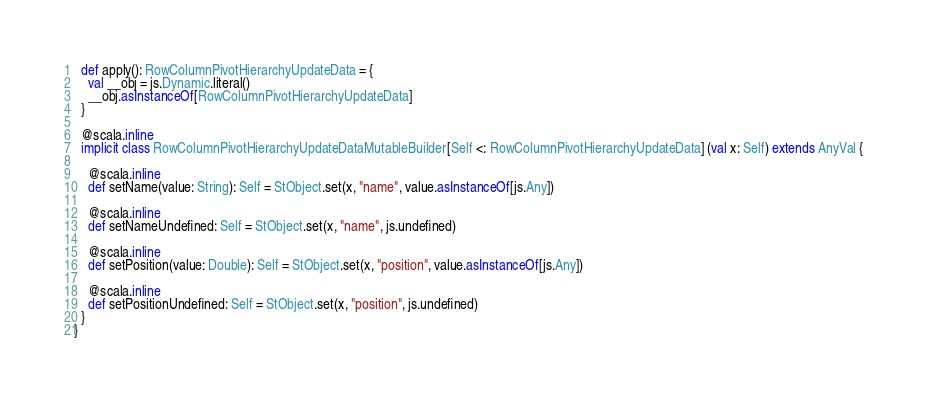Convert code to text. <code><loc_0><loc_0><loc_500><loc_500><_Scala_>  def apply(): RowColumnPivotHierarchyUpdateData = {
    val __obj = js.Dynamic.literal()
    __obj.asInstanceOf[RowColumnPivotHierarchyUpdateData]
  }
  
  @scala.inline
  implicit class RowColumnPivotHierarchyUpdateDataMutableBuilder[Self <: RowColumnPivotHierarchyUpdateData] (val x: Self) extends AnyVal {
    
    @scala.inline
    def setName(value: String): Self = StObject.set(x, "name", value.asInstanceOf[js.Any])
    
    @scala.inline
    def setNameUndefined: Self = StObject.set(x, "name", js.undefined)
    
    @scala.inline
    def setPosition(value: Double): Self = StObject.set(x, "position", value.asInstanceOf[js.Any])
    
    @scala.inline
    def setPositionUndefined: Self = StObject.set(x, "position", js.undefined)
  }
}
</code> 